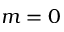<formula> <loc_0><loc_0><loc_500><loc_500>m = 0</formula> 